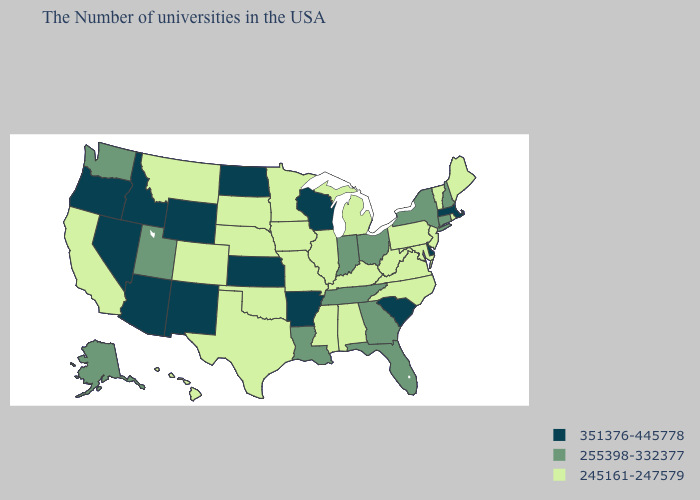Does North Carolina have the highest value in the South?
Answer briefly. No. Among the states that border New Mexico , does Texas have the lowest value?
Be succinct. Yes. Name the states that have a value in the range 255398-332377?
Short answer required. New Hampshire, Connecticut, New York, Ohio, Florida, Georgia, Indiana, Tennessee, Louisiana, Utah, Washington, Alaska. How many symbols are there in the legend?
Concise answer only. 3. Which states hav the highest value in the Northeast?
Give a very brief answer. Massachusetts. Name the states that have a value in the range 351376-445778?
Give a very brief answer. Massachusetts, Delaware, South Carolina, Wisconsin, Arkansas, Kansas, North Dakota, Wyoming, New Mexico, Arizona, Idaho, Nevada, Oregon. Is the legend a continuous bar?
Give a very brief answer. No. Does the map have missing data?
Short answer required. No. What is the value of Kansas?
Keep it brief. 351376-445778. Does Georgia have a lower value than South Dakota?
Quick response, please. No. Which states have the lowest value in the West?
Concise answer only. Colorado, Montana, California, Hawaii. What is the lowest value in states that border Nebraska?
Quick response, please. 245161-247579. Which states have the lowest value in the USA?
Short answer required. Maine, Rhode Island, Vermont, New Jersey, Maryland, Pennsylvania, Virginia, North Carolina, West Virginia, Michigan, Kentucky, Alabama, Illinois, Mississippi, Missouri, Minnesota, Iowa, Nebraska, Oklahoma, Texas, South Dakota, Colorado, Montana, California, Hawaii. Name the states that have a value in the range 351376-445778?
Short answer required. Massachusetts, Delaware, South Carolina, Wisconsin, Arkansas, Kansas, North Dakota, Wyoming, New Mexico, Arizona, Idaho, Nevada, Oregon. Among the states that border Maine , which have the highest value?
Give a very brief answer. New Hampshire. 